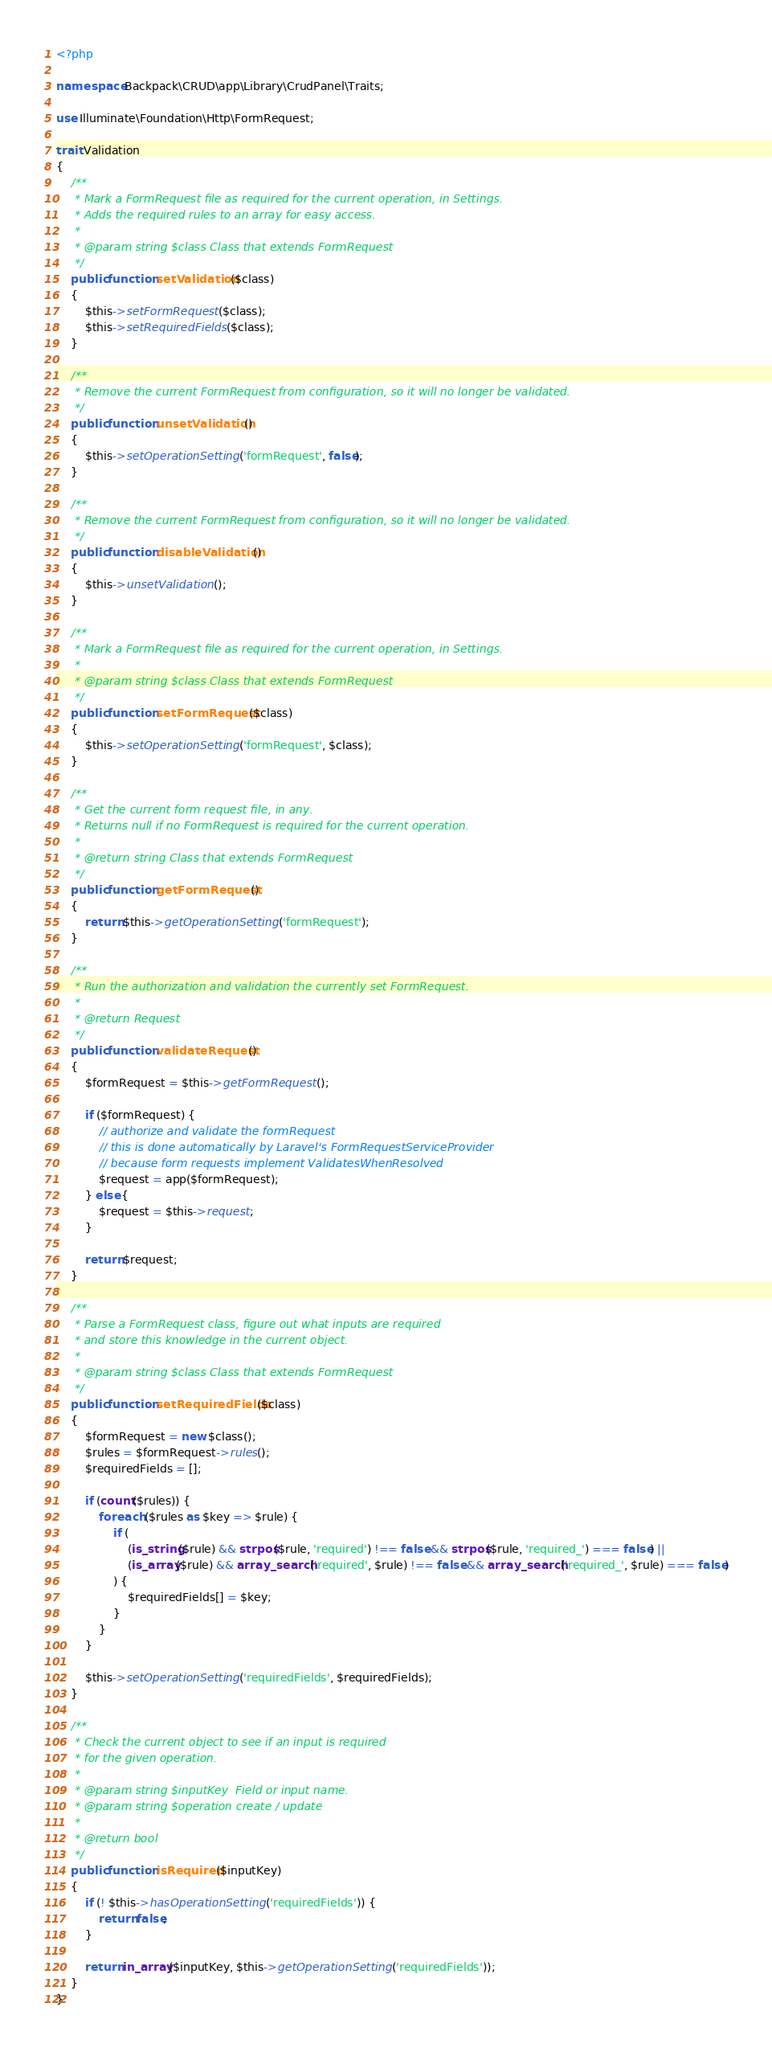<code> <loc_0><loc_0><loc_500><loc_500><_PHP_><?php

namespace Backpack\CRUD\app\Library\CrudPanel\Traits;

use Illuminate\Foundation\Http\FormRequest;

trait Validation
{
    /**
     * Mark a FormRequest file as required for the current operation, in Settings.
     * Adds the required rules to an array for easy access.
     *
     * @param string $class Class that extends FormRequest
     */
    public function setValidation($class)
    {
        $this->setFormRequest($class);
        $this->setRequiredFields($class);
    }

    /**
     * Remove the current FormRequest from configuration, so it will no longer be validated.
     */
    public function unsetValidation()
    {
        $this->setOperationSetting('formRequest', false);
    }

    /**
     * Remove the current FormRequest from configuration, so it will no longer be validated.
     */
    public function disableValidation()
    {
        $this->unsetValidation();
    }

    /**
     * Mark a FormRequest file as required for the current operation, in Settings.
     *
     * @param string $class Class that extends FormRequest
     */
    public function setFormRequest($class)
    {
        $this->setOperationSetting('formRequest', $class);
    }

    /**
     * Get the current form request file, in any.
     * Returns null if no FormRequest is required for the current operation.
     *
     * @return string Class that extends FormRequest
     */
    public function getFormRequest()
    {
        return $this->getOperationSetting('formRequest');
    }

    /**
     * Run the authorization and validation the currently set FormRequest.
     *
     * @return Request
     */
    public function validateRequest()
    {
        $formRequest = $this->getFormRequest();

        if ($formRequest) {
            // authorize and validate the formRequest
            // this is done automatically by Laravel's FormRequestServiceProvider
            // because form requests implement ValidatesWhenResolved
            $request = app($formRequest);
        } else {
            $request = $this->request;
        }

        return $request;
    }

    /**
     * Parse a FormRequest class, figure out what inputs are required
     * and store this knowledge in the current object.
     *
     * @param string $class Class that extends FormRequest
     */
    public function setRequiredFields($class)
    {
        $formRequest = new $class();
        $rules = $formRequest->rules();
        $requiredFields = [];

        if (count($rules)) {
            foreach ($rules as $key => $rule) {
                if (
                    (is_string($rule) && strpos($rule, 'required') !== false && strpos($rule, 'required_') === false) ||
                    (is_array($rule) && array_search('required', $rule) !== false && array_search('required_', $rule) === false)
                ) {
                    $requiredFields[] = $key;
                }
            }
        }

        $this->setOperationSetting('requiredFields', $requiredFields);
    }

    /**
     * Check the current object to see if an input is required
     * for the given operation.
     *
     * @param string $inputKey  Field or input name.
     * @param string $operation create / update
     *
     * @return bool
     */
    public function isRequired($inputKey)
    {
        if (! $this->hasOperationSetting('requiredFields')) {
            return false;
        }

        return in_array($inputKey, $this->getOperationSetting('requiredFields'));
    }
}
</code> 